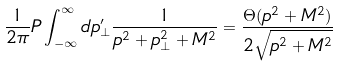Convert formula to latex. <formula><loc_0><loc_0><loc_500><loc_500>\frac { 1 } { 2 \pi } P \int _ { - \infty } ^ { \infty } d p _ { \perp } ^ { \prime } \frac { 1 } { p ^ { 2 } + p _ { \perp } ^ { 2 } + M ^ { 2 } } = \frac { \Theta ( p ^ { 2 } + M ^ { 2 } ) } { 2 \sqrt { p ^ { 2 } + M ^ { 2 } } }</formula> 